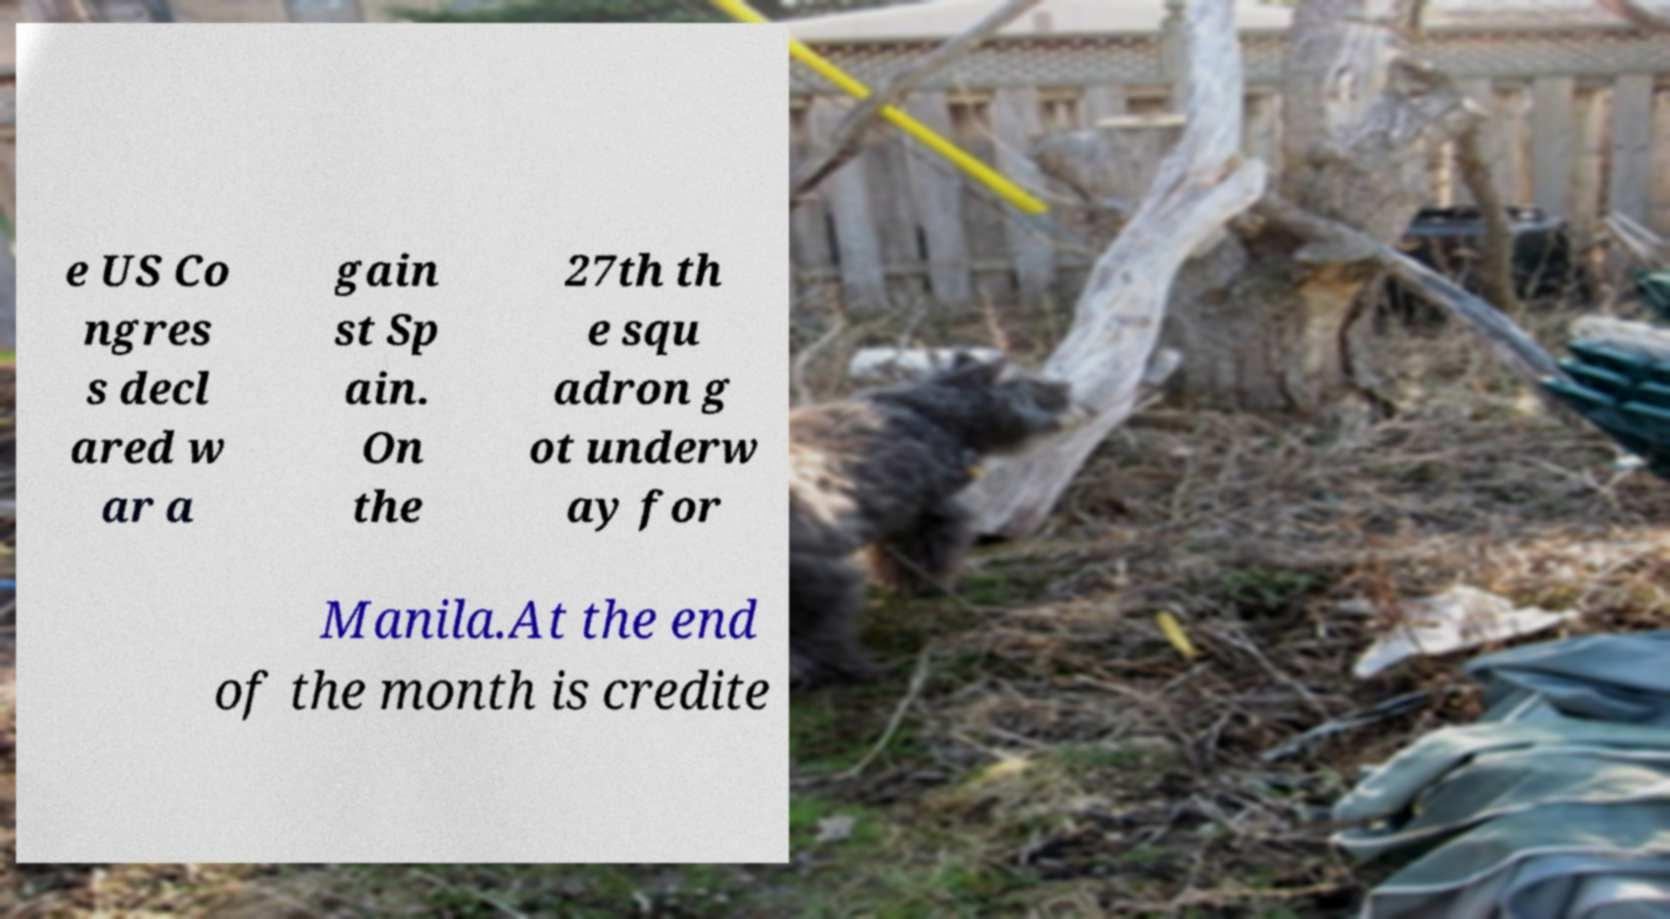Could you extract and type out the text from this image? e US Co ngres s decl ared w ar a gain st Sp ain. On the 27th th e squ adron g ot underw ay for Manila.At the end of the month is credite 